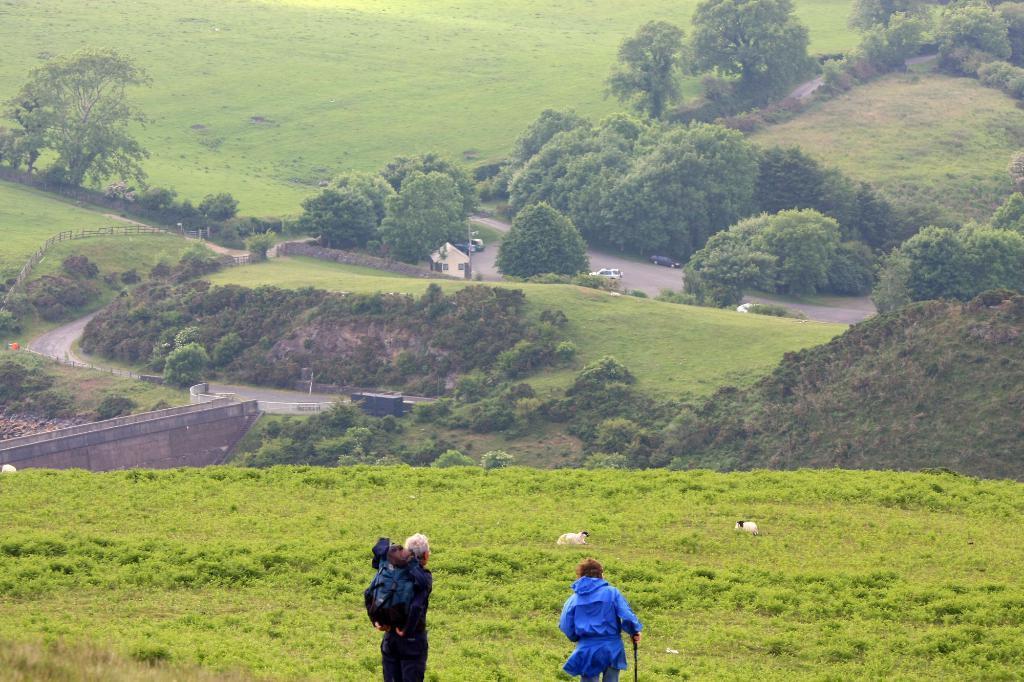Could you give a brief overview of what you see in this image? In this image we can see there is a woman and a person standing on the surface of the grass. The women hold a walking stick and the person holds the bag on his shoulder and there are two animals on the surface. In the background there are some vehicles on the road, plants and trees. 